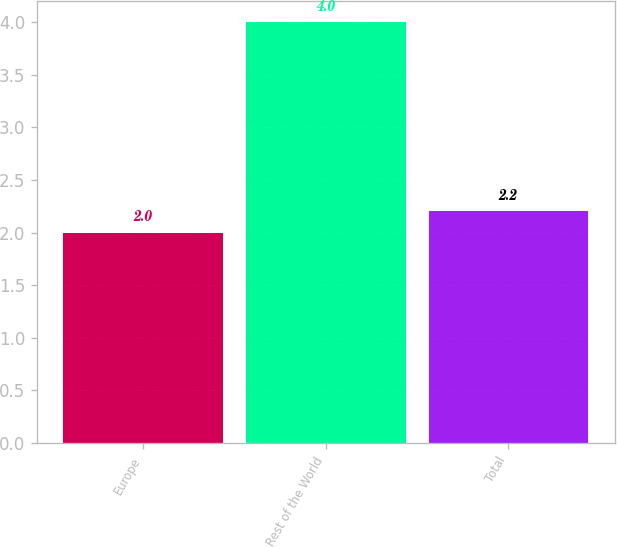Convert chart. <chart><loc_0><loc_0><loc_500><loc_500><bar_chart><fcel>Europe<fcel>Rest of the World<fcel>Total<nl><fcel>2<fcel>4<fcel>2.2<nl></chart> 